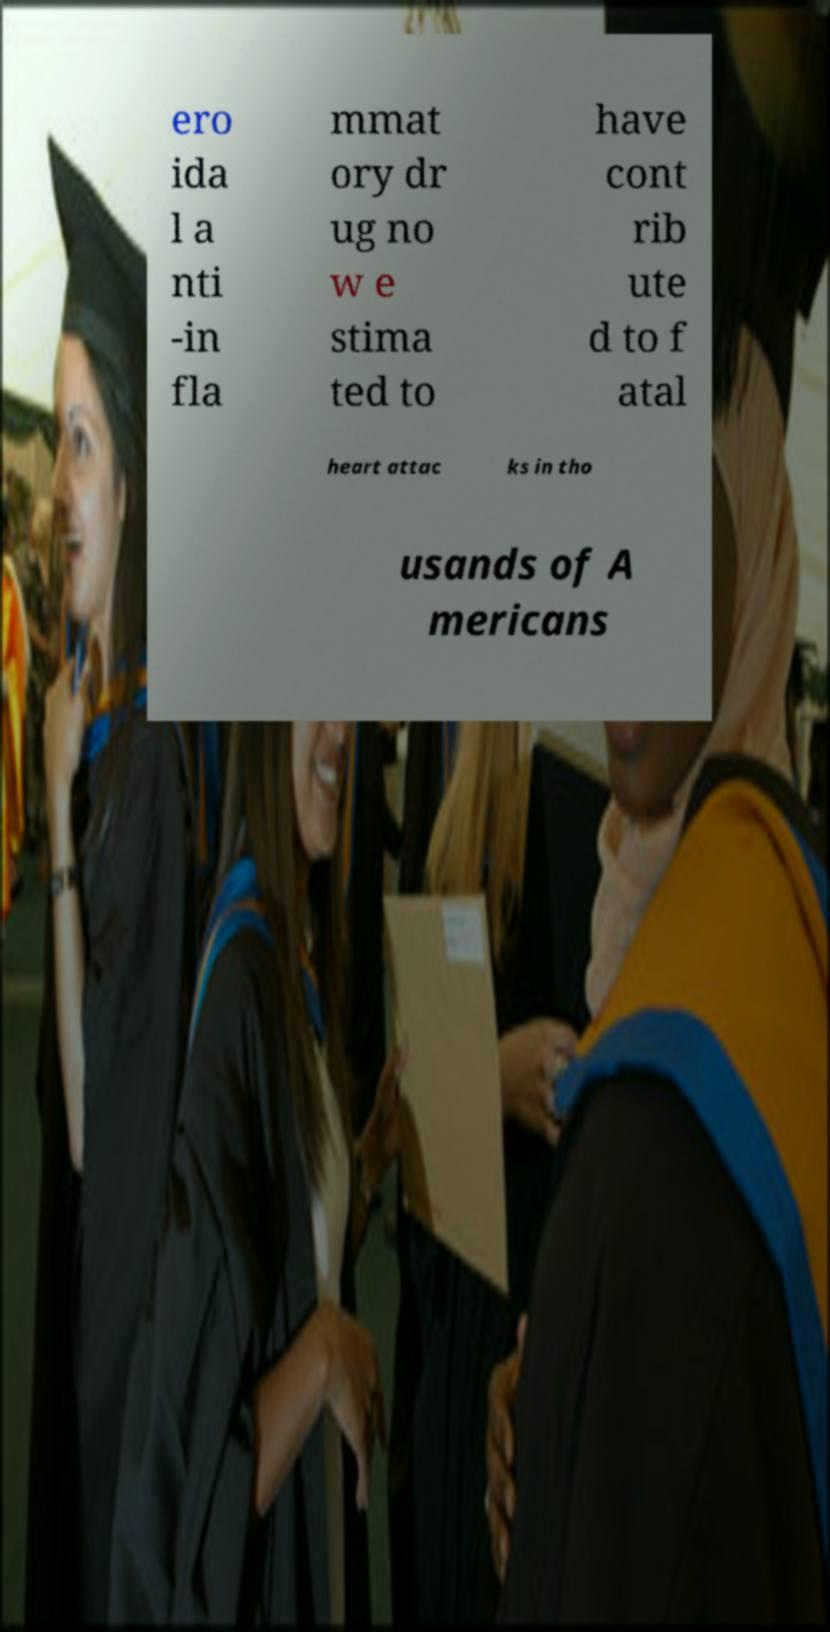Can you read and provide the text displayed in the image?This photo seems to have some interesting text. Can you extract and type it out for me? ero ida l a nti -in fla mmat ory dr ug no w e stima ted to have cont rib ute d to f atal heart attac ks in tho usands of A mericans 